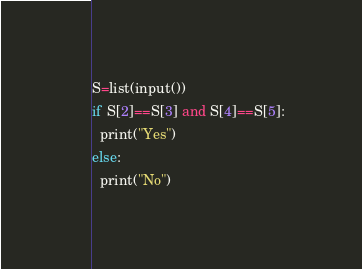Convert code to text. <code><loc_0><loc_0><loc_500><loc_500><_Python_>S=list(input())
if S[2]==S[3] and S[4]==S[5]:
  print("Yes")
else:
  print("No")
</code> 